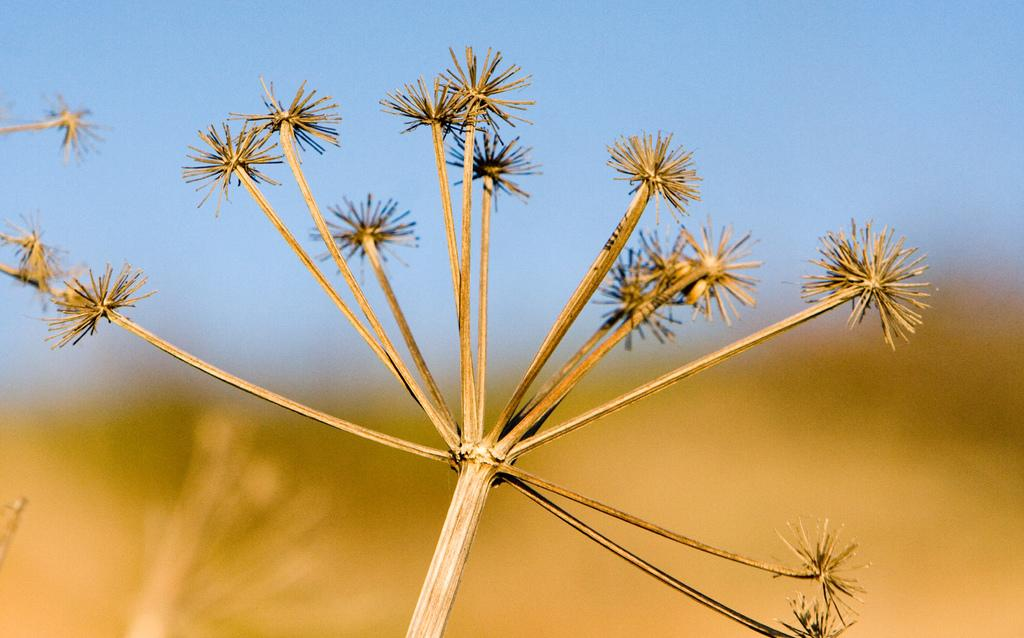What is the main subject in the foreground of the image? There is a plant in the foreground of the image. What can be observed about the background of the image? The background of the image is blurred. What type of disease is affecting the plant in the image? There is no indication of any disease affecting the plant in the image. How many bananas can be seen hanging from the plant in the image? There are no bananas present in the image, as it features a plant and not a banana tree. 